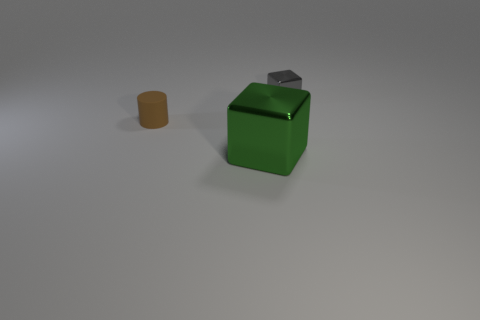Is there anything else that is the same size as the green block?
Give a very brief answer. No. What is the block to the left of the metallic block that is right of the big thing made of?
Your response must be concise. Metal. Do the object in front of the tiny rubber cylinder and the tiny brown cylinder have the same material?
Give a very brief answer. No. There is a metal object that is on the right side of the big shiny thing; what is its size?
Your response must be concise. Small. There is a small brown rubber object that is behind the green cube; are there any green things that are to the right of it?
Keep it short and to the point. Yes. What is the color of the large thing?
Give a very brief answer. Green. Are there any other things that are the same color as the large shiny cube?
Your response must be concise. No. What is the color of the object that is behind the green shiny cube and on the right side of the tiny brown thing?
Make the answer very short. Gray. Is the size of the cube that is to the right of the green metal cube the same as the brown rubber object?
Provide a short and direct response. Yes. Are there more big green metallic blocks to the right of the matte thing than small brown cylinders?
Offer a terse response. No. 